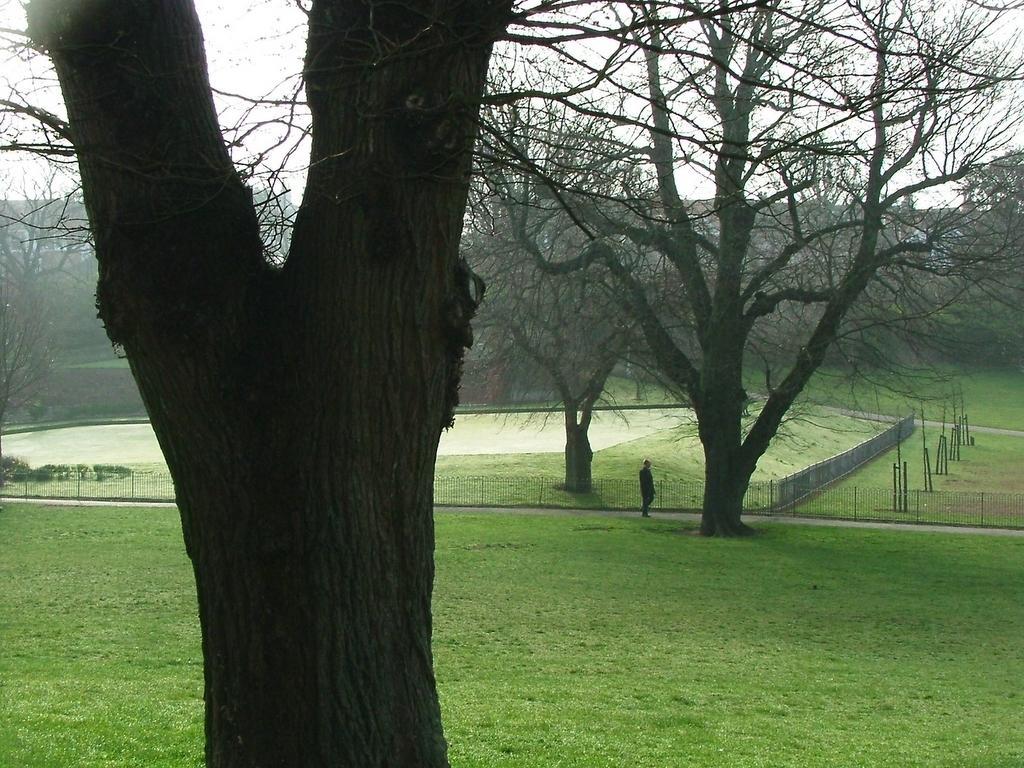Can you describe this image briefly? In this image we can see a person standing on the road, there are some trees, grass, poles, buildings, plants and the fence, in the background we can see the sky. 